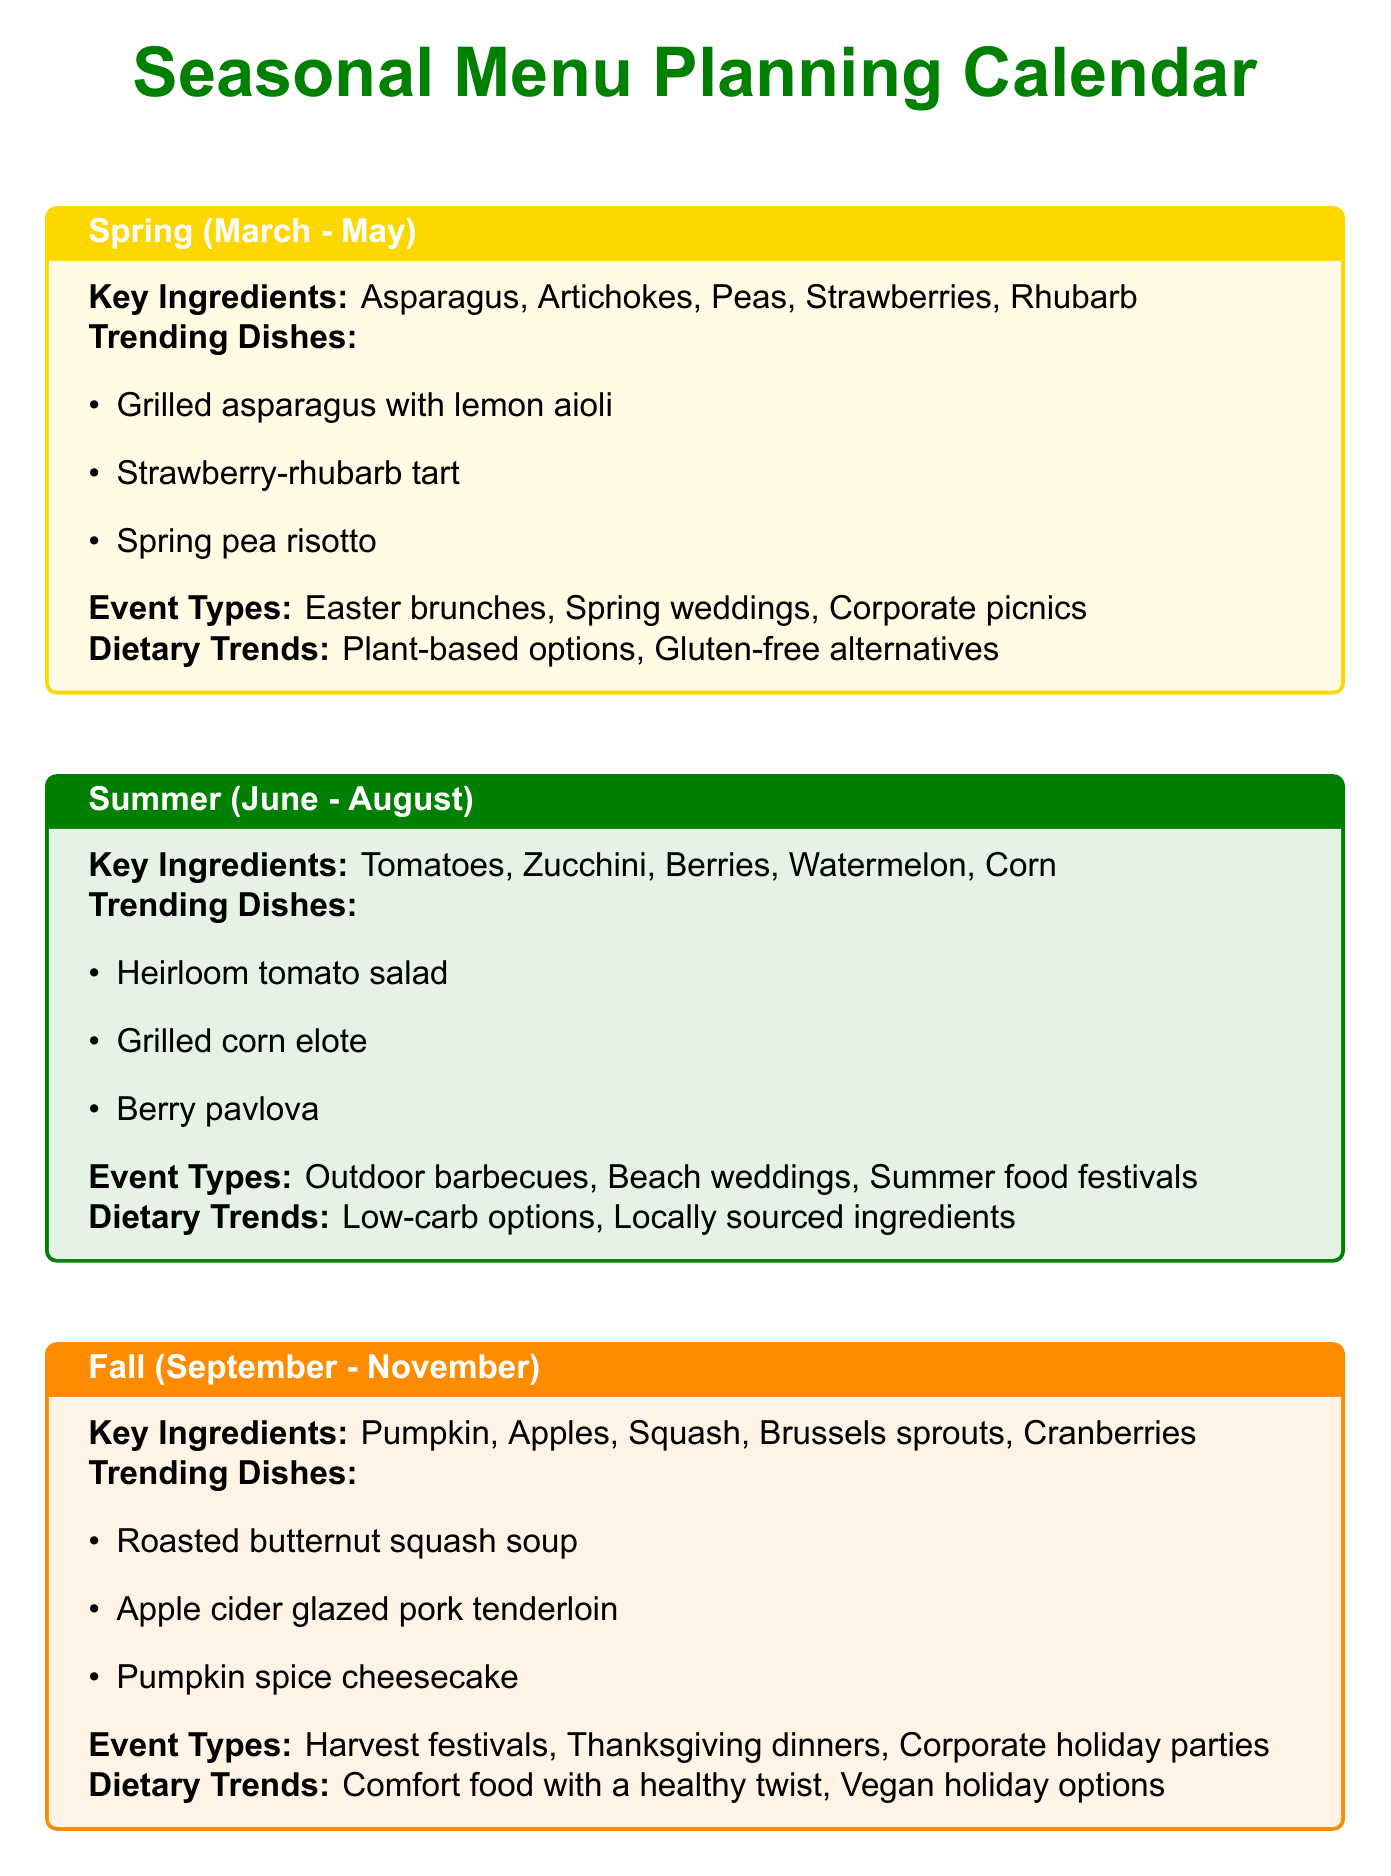What are the key ingredients in Summer? The key ingredients for Summer are listed as Tomatoes, Zucchini, Berries, Watermelon, and Corn.
Answer: Tomatoes, Zucchini, Berries, Watermelon, Corn What is the peak season for Pumpkins? The document states that the peak season for Pumpkins is from October to November.
Answer: October to November Which dietary trend is popular in Fall? The document mentions "Comfort food with a healthy twist" as a dietary trend in Fall.
Answer: Comfort food with a healthy twist What is a trending dish for Spring? The document lists "Grilled asparagus with lemon aioli" as a trending dish for Spring.
Answer: Grilled asparagus with lemon aioli What event type is associated with Winter? The document includes New Year's Eve galas as an event type in Winter.
Answer: New Year's Eve galas How should you adapt to unexpected dietary restrictions? The document advises keeping versatile ingredients for last-minute alterations.
Answer: Keep versatile ingredients What is a described trend in catering? The document mentions "Sustainable packaging" as a catering trend.
Answer: Sustainable packaging What substitutes can be used for Asparagus? The substitutes listed for Asparagus are Green beans and Broccoli.
Answer: Green beans, Broccoli Which dish features citrus fruits? The document states "Citrus-glazed salmon" as a dish featuring citrus fruits.
Answer: Citrus-glazed salmon 